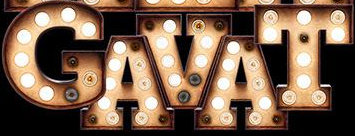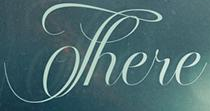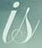What words are shown in these images in order, separated by a semicolon? GAVAT; There; is 